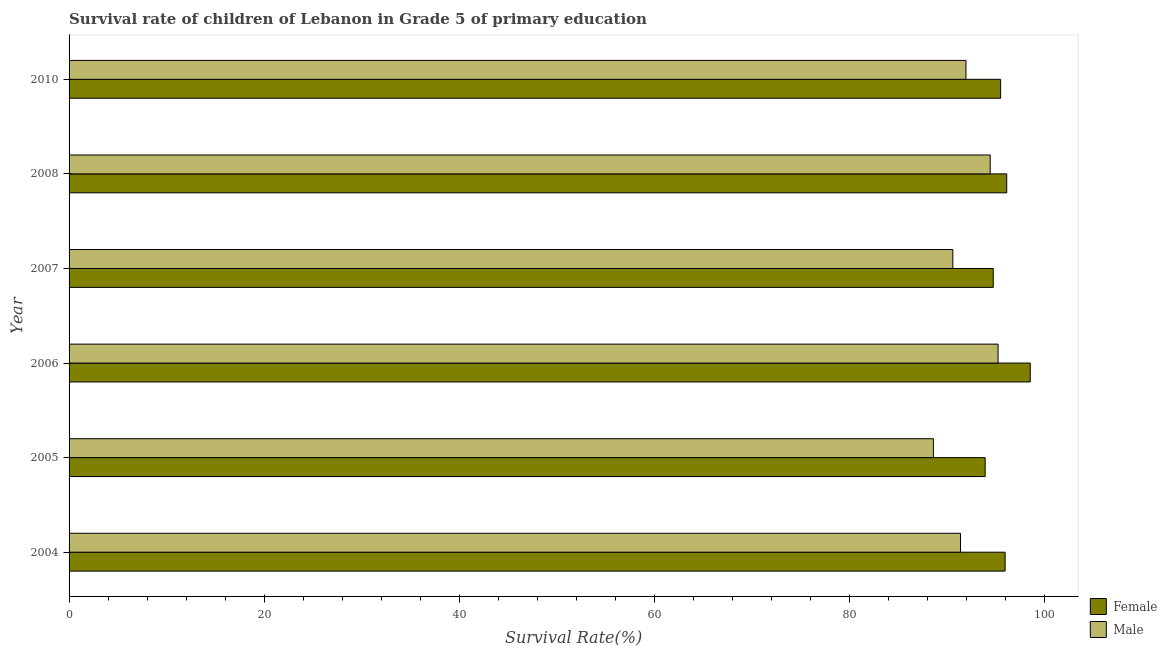How many different coloured bars are there?
Make the answer very short. 2. How many bars are there on the 6th tick from the bottom?
Make the answer very short. 2. In how many cases, is the number of bars for a given year not equal to the number of legend labels?
Ensure brevity in your answer.  0. What is the survival rate of female students in primary education in 2004?
Offer a terse response. 95.93. Across all years, what is the maximum survival rate of female students in primary education?
Offer a very short reply. 98.51. Across all years, what is the minimum survival rate of male students in primary education?
Your response must be concise. 88.59. In which year was the survival rate of male students in primary education maximum?
Provide a succinct answer. 2006. In which year was the survival rate of male students in primary education minimum?
Keep it short and to the point. 2005. What is the total survival rate of male students in primary education in the graph?
Your answer should be compact. 552.06. What is the difference between the survival rate of male students in primary education in 2004 and that in 2007?
Give a very brief answer. 0.79. What is the difference between the survival rate of male students in primary education in 2010 and the survival rate of female students in primary education in 2004?
Give a very brief answer. -4.01. What is the average survival rate of male students in primary education per year?
Offer a very short reply. 92.01. In the year 2008, what is the difference between the survival rate of female students in primary education and survival rate of male students in primary education?
Make the answer very short. 1.7. In how many years, is the survival rate of male students in primary education greater than 36 %?
Your response must be concise. 6. What is the ratio of the survival rate of female students in primary education in 2004 to that in 2005?
Your answer should be very brief. 1.02. Is the survival rate of male students in primary education in 2005 less than that in 2007?
Provide a short and direct response. Yes. What is the difference between the highest and the second highest survival rate of male students in primary education?
Provide a short and direct response. 0.81. What is the difference between the highest and the lowest survival rate of male students in primary education?
Ensure brevity in your answer.  6.63. In how many years, is the survival rate of female students in primary education greater than the average survival rate of female students in primary education taken over all years?
Keep it short and to the point. 3. How many bars are there?
Give a very brief answer. 12. Are all the bars in the graph horizontal?
Make the answer very short. Yes. Are the values on the major ticks of X-axis written in scientific E-notation?
Your answer should be very brief. No. Does the graph contain any zero values?
Provide a short and direct response. No. Where does the legend appear in the graph?
Make the answer very short. Bottom right. How many legend labels are there?
Offer a terse response. 2. How are the legend labels stacked?
Give a very brief answer. Vertical. What is the title of the graph?
Provide a short and direct response. Survival rate of children of Lebanon in Grade 5 of primary education. Does "Manufacturing industries and construction" appear as one of the legend labels in the graph?
Your answer should be compact. No. What is the label or title of the X-axis?
Offer a very short reply. Survival Rate(%). What is the label or title of the Y-axis?
Your answer should be very brief. Year. What is the Survival Rate(%) of Female in 2004?
Keep it short and to the point. 95.93. What is the Survival Rate(%) in Male in 2004?
Offer a very short reply. 91.36. What is the Survival Rate(%) of Female in 2005?
Provide a succinct answer. 93.89. What is the Survival Rate(%) of Male in 2005?
Give a very brief answer. 88.59. What is the Survival Rate(%) in Female in 2006?
Keep it short and to the point. 98.51. What is the Survival Rate(%) of Male in 2006?
Give a very brief answer. 95.21. What is the Survival Rate(%) in Female in 2007?
Keep it short and to the point. 94.72. What is the Survival Rate(%) in Male in 2007?
Provide a succinct answer. 90.58. What is the Survival Rate(%) of Female in 2008?
Offer a terse response. 96.1. What is the Survival Rate(%) of Male in 2008?
Keep it short and to the point. 94.4. What is the Survival Rate(%) of Female in 2010?
Your answer should be compact. 95.48. What is the Survival Rate(%) in Male in 2010?
Provide a succinct answer. 91.92. Across all years, what is the maximum Survival Rate(%) in Female?
Your response must be concise. 98.51. Across all years, what is the maximum Survival Rate(%) of Male?
Give a very brief answer. 95.21. Across all years, what is the minimum Survival Rate(%) in Female?
Your response must be concise. 93.89. Across all years, what is the minimum Survival Rate(%) of Male?
Provide a succinct answer. 88.59. What is the total Survival Rate(%) in Female in the graph?
Keep it short and to the point. 574.63. What is the total Survival Rate(%) in Male in the graph?
Provide a short and direct response. 552.06. What is the difference between the Survival Rate(%) in Female in 2004 and that in 2005?
Offer a terse response. 2.04. What is the difference between the Survival Rate(%) of Male in 2004 and that in 2005?
Provide a succinct answer. 2.78. What is the difference between the Survival Rate(%) in Female in 2004 and that in 2006?
Your answer should be compact. -2.58. What is the difference between the Survival Rate(%) in Male in 2004 and that in 2006?
Make the answer very short. -3.85. What is the difference between the Survival Rate(%) of Female in 2004 and that in 2007?
Keep it short and to the point. 1.22. What is the difference between the Survival Rate(%) in Male in 2004 and that in 2007?
Ensure brevity in your answer.  0.79. What is the difference between the Survival Rate(%) in Female in 2004 and that in 2008?
Your answer should be very brief. -0.17. What is the difference between the Survival Rate(%) of Male in 2004 and that in 2008?
Provide a succinct answer. -3.04. What is the difference between the Survival Rate(%) in Female in 2004 and that in 2010?
Offer a terse response. 0.46. What is the difference between the Survival Rate(%) of Male in 2004 and that in 2010?
Keep it short and to the point. -0.56. What is the difference between the Survival Rate(%) of Female in 2005 and that in 2006?
Give a very brief answer. -4.62. What is the difference between the Survival Rate(%) of Male in 2005 and that in 2006?
Offer a very short reply. -6.63. What is the difference between the Survival Rate(%) of Female in 2005 and that in 2007?
Your answer should be compact. -0.83. What is the difference between the Survival Rate(%) of Male in 2005 and that in 2007?
Your response must be concise. -1.99. What is the difference between the Survival Rate(%) in Female in 2005 and that in 2008?
Provide a short and direct response. -2.21. What is the difference between the Survival Rate(%) of Male in 2005 and that in 2008?
Your response must be concise. -5.82. What is the difference between the Survival Rate(%) of Female in 2005 and that in 2010?
Offer a terse response. -1.58. What is the difference between the Survival Rate(%) of Male in 2005 and that in 2010?
Provide a succinct answer. -3.34. What is the difference between the Survival Rate(%) of Female in 2006 and that in 2007?
Your answer should be compact. 3.79. What is the difference between the Survival Rate(%) of Male in 2006 and that in 2007?
Make the answer very short. 4.63. What is the difference between the Survival Rate(%) of Female in 2006 and that in 2008?
Make the answer very short. 2.41. What is the difference between the Survival Rate(%) of Male in 2006 and that in 2008?
Your response must be concise. 0.81. What is the difference between the Survival Rate(%) of Female in 2006 and that in 2010?
Give a very brief answer. 3.03. What is the difference between the Survival Rate(%) of Male in 2006 and that in 2010?
Keep it short and to the point. 3.29. What is the difference between the Survival Rate(%) of Female in 2007 and that in 2008?
Ensure brevity in your answer.  -1.38. What is the difference between the Survival Rate(%) in Male in 2007 and that in 2008?
Keep it short and to the point. -3.83. What is the difference between the Survival Rate(%) in Female in 2007 and that in 2010?
Make the answer very short. -0.76. What is the difference between the Survival Rate(%) of Male in 2007 and that in 2010?
Your answer should be compact. -1.34. What is the difference between the Survival Rate(%) in Female in 2008 and that in 2010?
Provide a short and direct response. 0.62. What is the difference between the Survival Rate(%) of Male in 2008 and that in 2010?
Your answer should be compact. 2.48. What is the difference between the Survival Rate(%) of Female in 2004 and the Survival Rate(%) of Male in 2005?
Keep it short and to the point. 7.35. What is the difference between the Survival Rate(%) in Female in 2004 and the Survival Rate(%) in Male in 2006?
Provide a short and direct response. 0.72. What is the difference between the Survival Rate(%) in Female in 2004 and the Survival Rate(%) in Male in 2007?
Offer a very short reply. 5.36. What is the difference between the Survival Rate(%) of Female in 2004 and the Survival Rate(%) of Male in 2008?
Provide a short and direct response. 1.53. What is the difference between the Survival Rate(%) in Female in 2004 and the Survival Rate(%) in Male in 2010?
Your response must be concise. 4.01. What is the difference between the Survival Rate(%) of Female in 2005 and the Survival Rate(%) of Male in 2006?
Your answer should be compact. -1.32. What is the difference between the Survival Rate(%) of Female in 2005 and the Survival Rate(%) of Male in 2007?
Your response must be concise. 3.31. What is the difference between the Survival Rate(%) of Female in 2005 and the Survival Rate(%) of Male in 2008?
Make the answer very short. -0.51. What is the difference between the Survival Rate(%) of Female in 2005 and the Survival Rate(%) of Male in 2010?
Your answer should be very brief. 1.97. What is the difference between the Survival Rate(%) of Female in 2006 and the Survival Rate(%) of Male in 2007?
Provide a succinct answer. 7.93. What is the difference between the Survival Rate(%) in Female in 2006 and the Survival Rate(%) in Male in 2008?
Your response must be concise. 4.11. What is the difference between the Survival Rate(%) of Female in 2006 and the Survival Rate(%) of Male in 2010?
Provide a succinct answer. 6.59. What is the difference between the Survival Rate(%) of Female in 2007 and the Survival Rate(%) of Male in 2008?
Keep it short and to the point. 0.31. What is the difference between the Survival Rate(%) of Female in 2007 and the Survival Rate(%) of Male in 2010?
Offer a very short reply. 2.8. What is the difference between the Survival Rate(%) in Female in 2008 and the Survival Rate(%) in Male in 2010?
Your answer should be compact. 4.18. What is the average Survival Rate(%) in Female per year?
Keep it short and to the point. 95.77. What is the average Survival Rate(%) in Male per year?
Keep it short and to the point. 92.01. In the year 2004, what is the difference between the Survival Rate(%) in Female and Survival Rate(%) in Male?
Offer a very short reply. 4.57. In the year 2005, what is the difference between the Survival Rate(%) of Female and Survival Rate(%) of Male?
Provide a succinct answer. 5.31. In the year 2006, what is the difference between the Survival Rate(%) of Female and Survival Rate(%) of Male?
Provide a short and direct response. 3.3. In the year 2007, what is the difference between the Survival Rate(%) of Female and Survival Rate(%) of Male?
Provide a short and direct response. 4.14. In the year 2008, what is the difference between the Survival Rate(%) in Female and Survival Rate(%) in Male?
Make the answer very short. 1.7. In the year 2010, what is the difference between the Survival Rate(%) of Female and Survival Rate(%) of Male?
Give a very brief answer. 3.55. What is the ratio of the Survival Rate(%) of Female in 2004 to that in 2005?
Keep it short and to the point. 1.02. What is the ratio of the Survival Rate(%) of Male in 2004 to that in 2005?
Offer a terse response. 1.03. What is the ratio of the Survival Rate(%) of Female in 2004 to that in 2006?
Keep it short and to the point. 0.97. What is the ratio of the Survival Rate(%) in Male in 2004 to that in 2006?
Make the answer very short. 0.96. What is the ratio of the Survival Rate(%) of Female in 2004 to that in 2007?
Provide a short and direct response. 1.01. What is the ratio of the Survival Rate(%) of Male in 2004 to that in 2007?
Keep it short and to the point. 1.01. What is the ratio of the Survival Rate(%) in Female in 2004 to that in 2008?
Offer a terse response. 1. What is the ratio of the Survival Rate(%) of Male in 2004 to that in 2008?
Offer a very short reply. 0.97. What is the ratio of the Survival Rate(%) in Female in 2004 to that in 2010?
Make the answer very short. 1. What is the ratio of the Survival Rate(%) of Female in 2005 to that in 2006?
Your answer should be compact. 0.95. What is the ratio of the Survival Rate(%) of Male in 2005 to that in 2006?
Your answer should be compact. 0.93. What is the ratio of the Survival Rate(%) of Female in 2005 to that in 2007?
Your answer should be compact. 0.99. What is the ratio of the Survival Rate(%) of Female in 2005 to that in 2008?
Offer a very short reply. 0.98. What is the ratio of the Survival Rate(%) of Male in 2005 to that in 2008?
Offer a very short reply. 0.94. What is the ratio of the Survival Rate(%) in Female in 2005 to that in 2010?
Make the answer very short. 0.98. What is the ratio of the Survival Rate(%) in Male in 2005 to that in 2010?
Make the answer very short. 0.96. What is the ratio of the Survival Rate(%) of Male in 2006 to that in 2007?
Make the answer very short. 1.05. What is the ratio of the Survival Rate(%) of Female in 2006 to that in 2008?
Your answer should be very brief. 1.03. What is the ratio of the Survival Rate(%) in Male in 2006 to that in 2008?
Your answer should be very brief. 1.01. What is the ratio of the Survival Rate(%) in Female in 2006 to that in 2010?
Provide a succinct answer. 1.03. What is the ratio of the Survival Rate(%) of Male in 2006 to that in 2010?
Offer a terse response. 1.04. What is the ratio of the Survival Rate(%) in Female in 2007 to that in 2008?
Give a very brief answer. 0.99. What is the ratio of the Survival Rate(%) in Male in 2007 to that in 2008?
Offer a terse response. 0.96. What is the ratio of the Survival Rate(%) in Female in 2007 to that in 2010?
Offer a very short reply. 0.99. What is the ratio of the Survival Rate(%) in Male in 2007 to that in 2010?
Your answer should be compact. 0.99. What is the ratio of the Survival Rate(%) of Male in 2008 to that in 2010?
Offer a terse response. 1.03. What is the difference between the highest and the second highest Survival Rate(%) in Female?
Make the answer very short. 2.41. What is the difference between the highest and the second highest Survival Rate(%) in Male?
Provide a short and direct response. 0.81. What is the difference between the highest and the lowest Survival Rate(%) of Female?
Make the answer very short. 4.62. What is the difference between the highest and the lowest Survival Rate(%) in Male?
Offer a terse response. 6.63. 